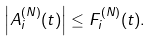<formula> <loc_0><loc_0><loc_500><loc_500>\left | A _ { i } ^ { ( N ) } ( t ) \right | \leq F _ { i } ^ { ( N ) } ( t ) .</formula> 